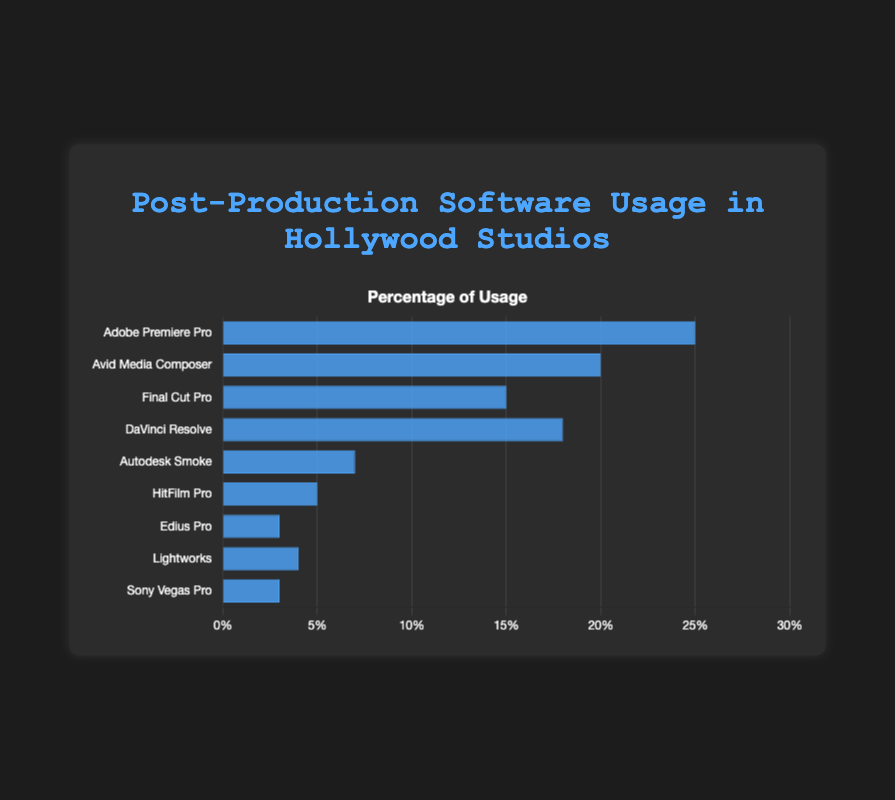What's the most used post-production software among Hollywood studios? The figure shows a bar chart with various software and their usage percentages. Adobe Premiere Pro has the tallest bar representing 25%, making it the most used software among Hollywood studios.
Answer: Adobe Premiere Pro Which post-production software has the least usage percentage? By visually comparing the heights of the bars, Sony Vegas Pro and Edius Pro both have the shortest bars, each representing 3% usage.
Answer: Sony Vegas Pro and Edius Pro How much higher is the usage percentage of Adobe Premiere Pro compared to Final Cut Pro? Adobe Premiere Pro has a usage percentage of 25%, and Final Cut Pro has 15%. The difference is calculated as 25% - 15% = 10%.
Answer: 10% What is the combined usage percentage of DaVinci Resolve and Avid Media Composer? DaVinci Resolve has a usage percentage of 18%, and Avid Media Composer has 20%. The combined usage is 18% + 20% = 38%.
Answer: 38% Which software has a higher usage percentage: Lightworks or HitFilm Pro? Lightworks has a usage percentage of 4%, and HitFilm Pro has 5%. Comparing the two, HitFilm Pro has a higher usage percentage.
Answer: HitFilm Pro What is the average usage percentage of all the software listed? Sum the usage percentages and divide by the number of software: (25 + 20 + 15 + 18 + 7 + 5 + 3 + 4 + 3) = 100, and there are 9 software entries. The average is 100 / 9 ≈ 11.11%.
Answer: 11.11% How much lower is the usage percentage of Autodesk Smoke compared to DaVinci Resolve? Autodesk Smoke has a usage percentage of 7%, and DaVinci Resolve has 18%. The difference is 18% - 7% = 11%.
Answer: 11% Which software’s usage percentage is closest to the median value of all percentages? First, list the percentages in ascending order: 3, 3, 4, 5, 7, 15, 18, 20, 25. The median value in this odd-numbered set is 7%. Therefore, Autodesk Smoke, with 7%, is closest to the median value.
Answer: Autodesk Smoke What is the total percentage of usage for software that have less than 10% usage? The software with less than 10% usage are Autodesk Smoke (7%), HitFilm Pro (5%), Edius Pro (3%), Lightworks (4%), and Sony Vegas Pro (3%). The total usage is 7% + 5% + 3% + 4% + 3% = 22%.
Answer: 22% Is the usage percentage of Avid Media Composer greater than the combined usage of Edius Pro and Lightworks? Avid Media Composer has a 20% usage percentage. Edius Pro has 3%, and Lightworks has 4%. Their combined usage is 3% + 4% = 7%. Since 20% is greater than 7%, the answer is yes.
Answer: Yes 